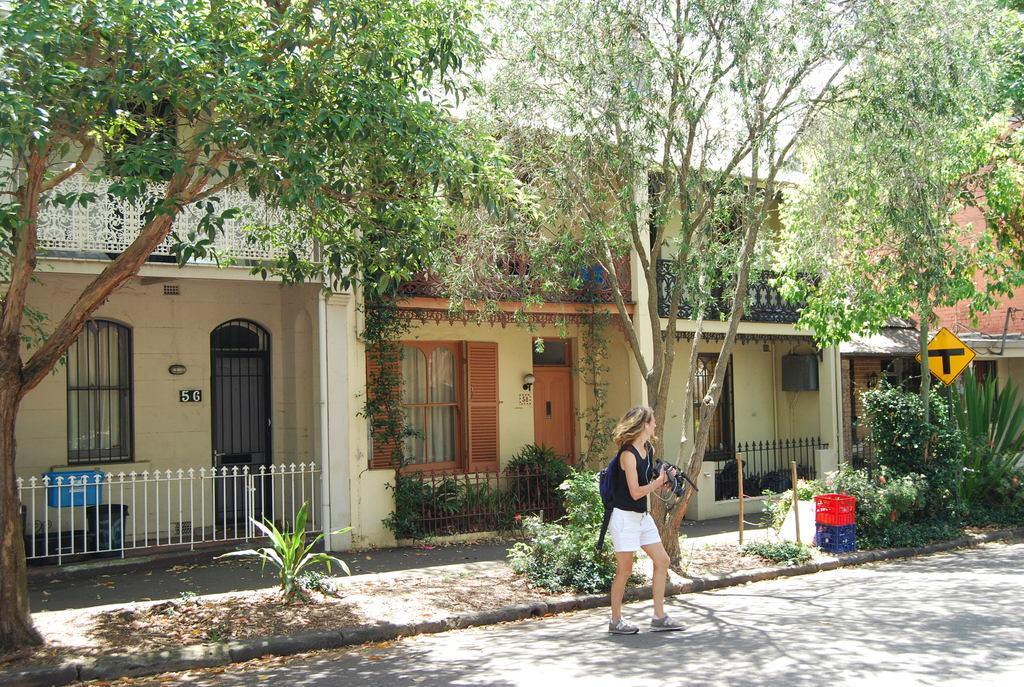How would you summarize this image in a sentence or two? This image is taken outdoors. At the bottom of the image there is a road. In the middle of the image a woman is standing on the road and she is holding a camera in her hands. In the background there are a few trees and plants and there is a house with walls, windows, doors, railing and roofs. 